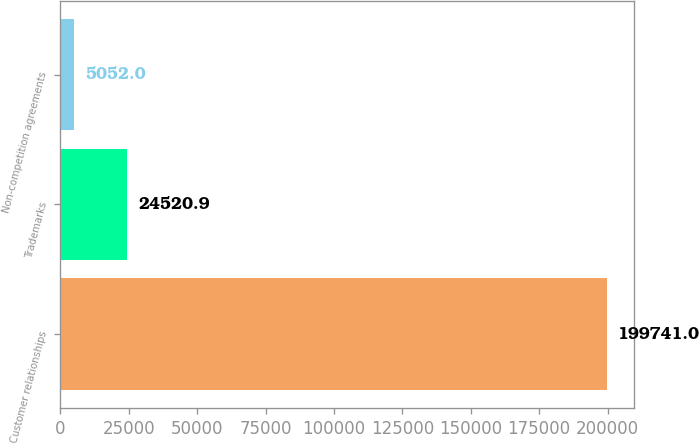<chart> <loc_0><loc_0><loc_500><loc_500><bar_chart><fcel>Customer relationships<fcel>Trademarks<fcel>Non-competition agreements<nl><fcel>199741<fcel>24520.9<fcel>5052<nl></chart> 